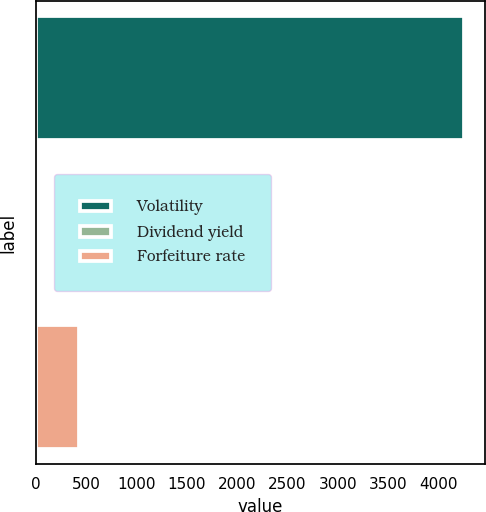<chart> <loc_0><loc_0><loc_500><loc_500><bar_chart><fcel>Volatility<fcel>Dividend yield<fcel>Forfeiture rate<nl><fcel>4248<fcel>4.03<fcel>428.43<nl></chart> 